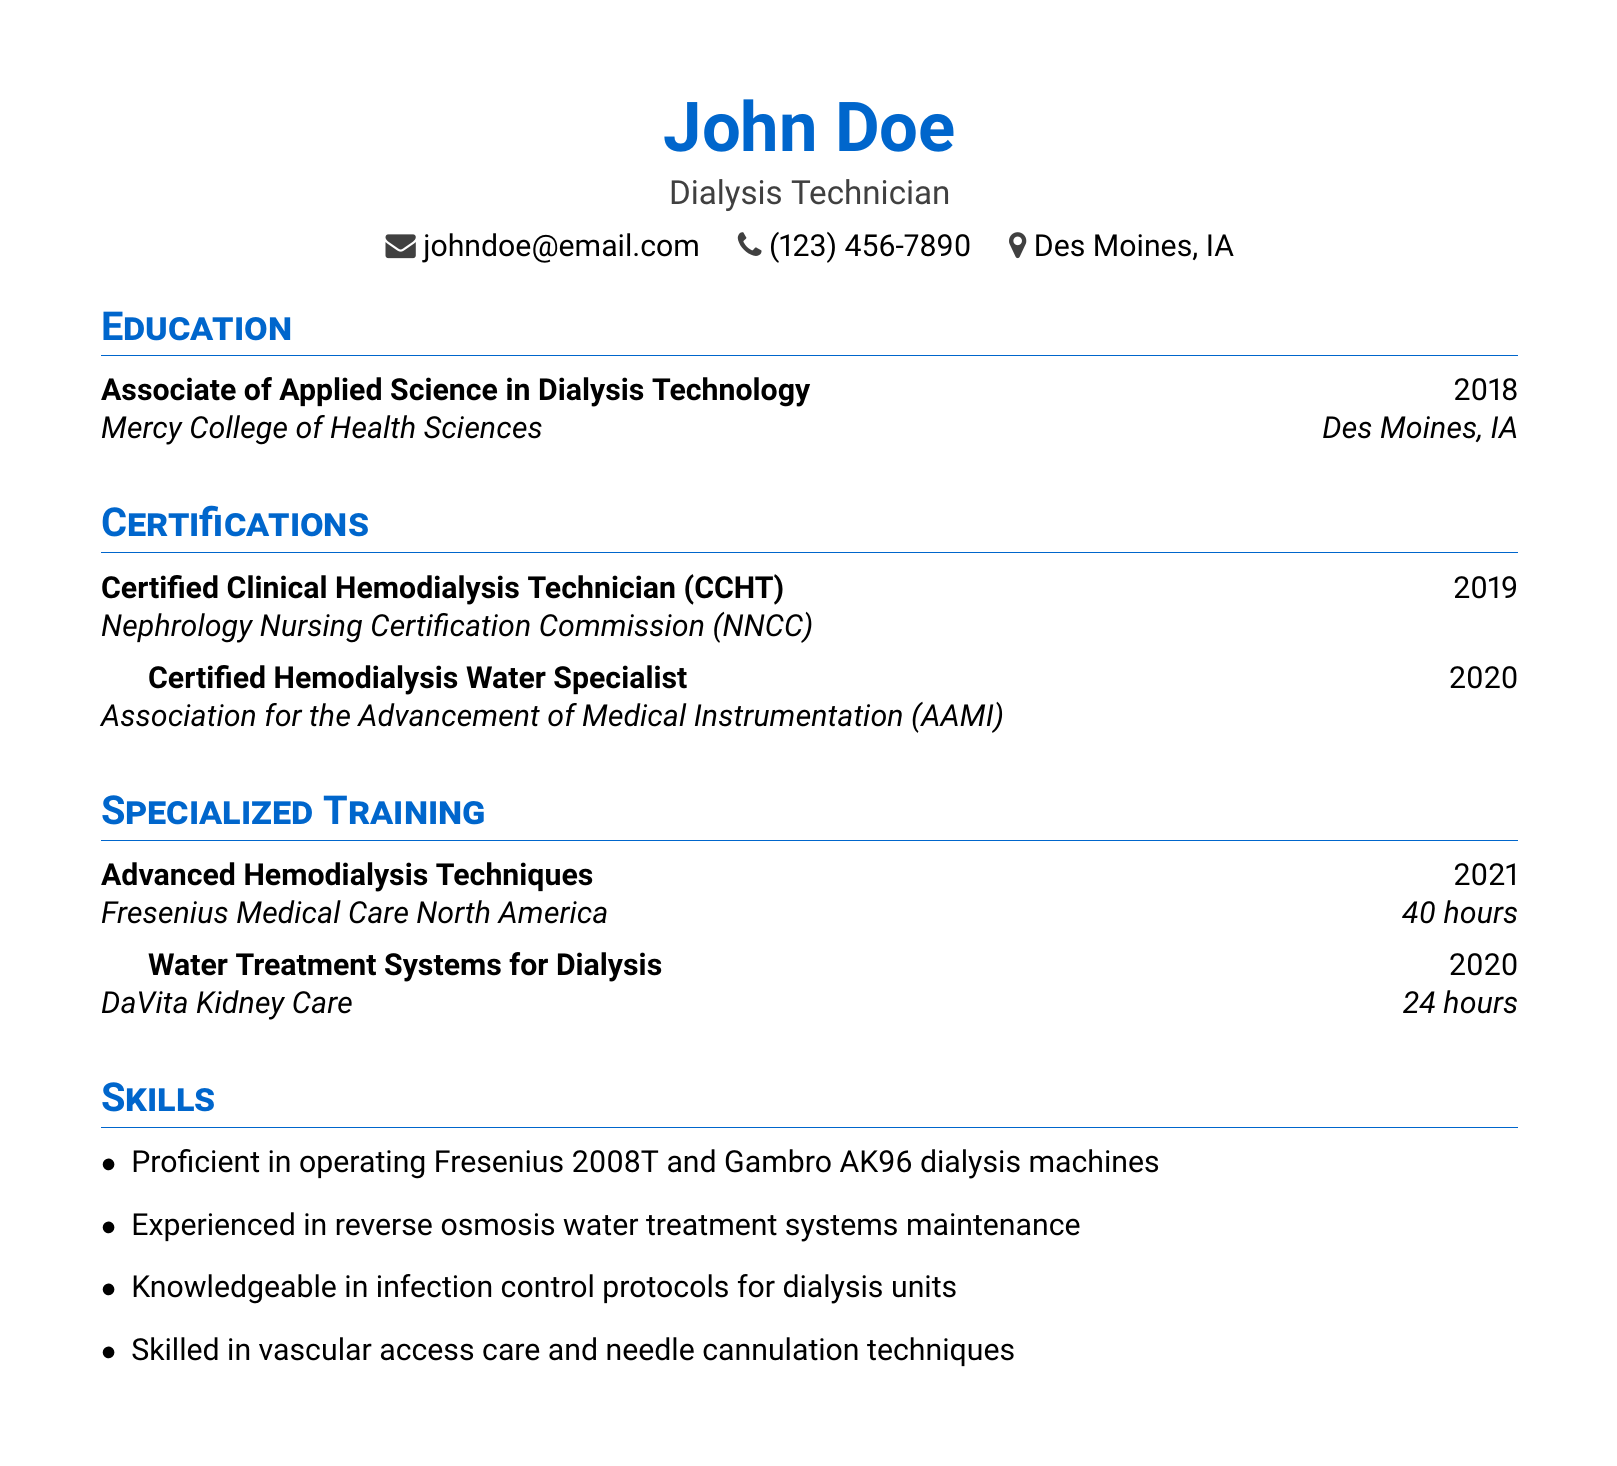What degree did John Doe obtain? The document states that John Doe earned an Associate of Applied Science in Dialysis Technology.
Answer: Associate of Applied Science in Dialysis Technology In which year did John Doe receive the CCHT certification? The CCHT certification was obtained by John Doe in 2019 as mentioned in the certifications section.
Answer: 2019 How many hours of training did John Doe complete in Advanced Hemodialysis Techniques? The document notes that John Doe completed 40 hours of training in this specialized course.
Answer: 40 hours What institution offered the Water Treatment Systems for Dialysis course? The document specifies that DaVita Kidney Care provided the training for Water Treatment Systems for Dialysis.
Answer: DaVita Kidney Care Which dialysis machines is John Doe proficient in operating? The skills section mentions proficiency in Fresenius 2008T and Gambro AK96 dialysis machines.
Answer: Fresenius 2008T and Gambro AK96 What is the location of John Doe’s education? The education section indicates that Mercy College of Health Sciences is located in Des Moines, IA.
Answer: Des Moines, IA What certification was earned from AAMI? The document indicates that John Doe is a Certified Hemodialysis Water Specialist, which was certified by AAMI.
Answer: Certified Hemodialysis Water Specialist How many specialized training courses are listed in the document? The document details two specialized training courses completed by John Doe.
Answer: Two What professional role is John Doe associated with? The top of the document identifies John Doe as a Dialysis Technician.
Answer: Dialysis Technician 